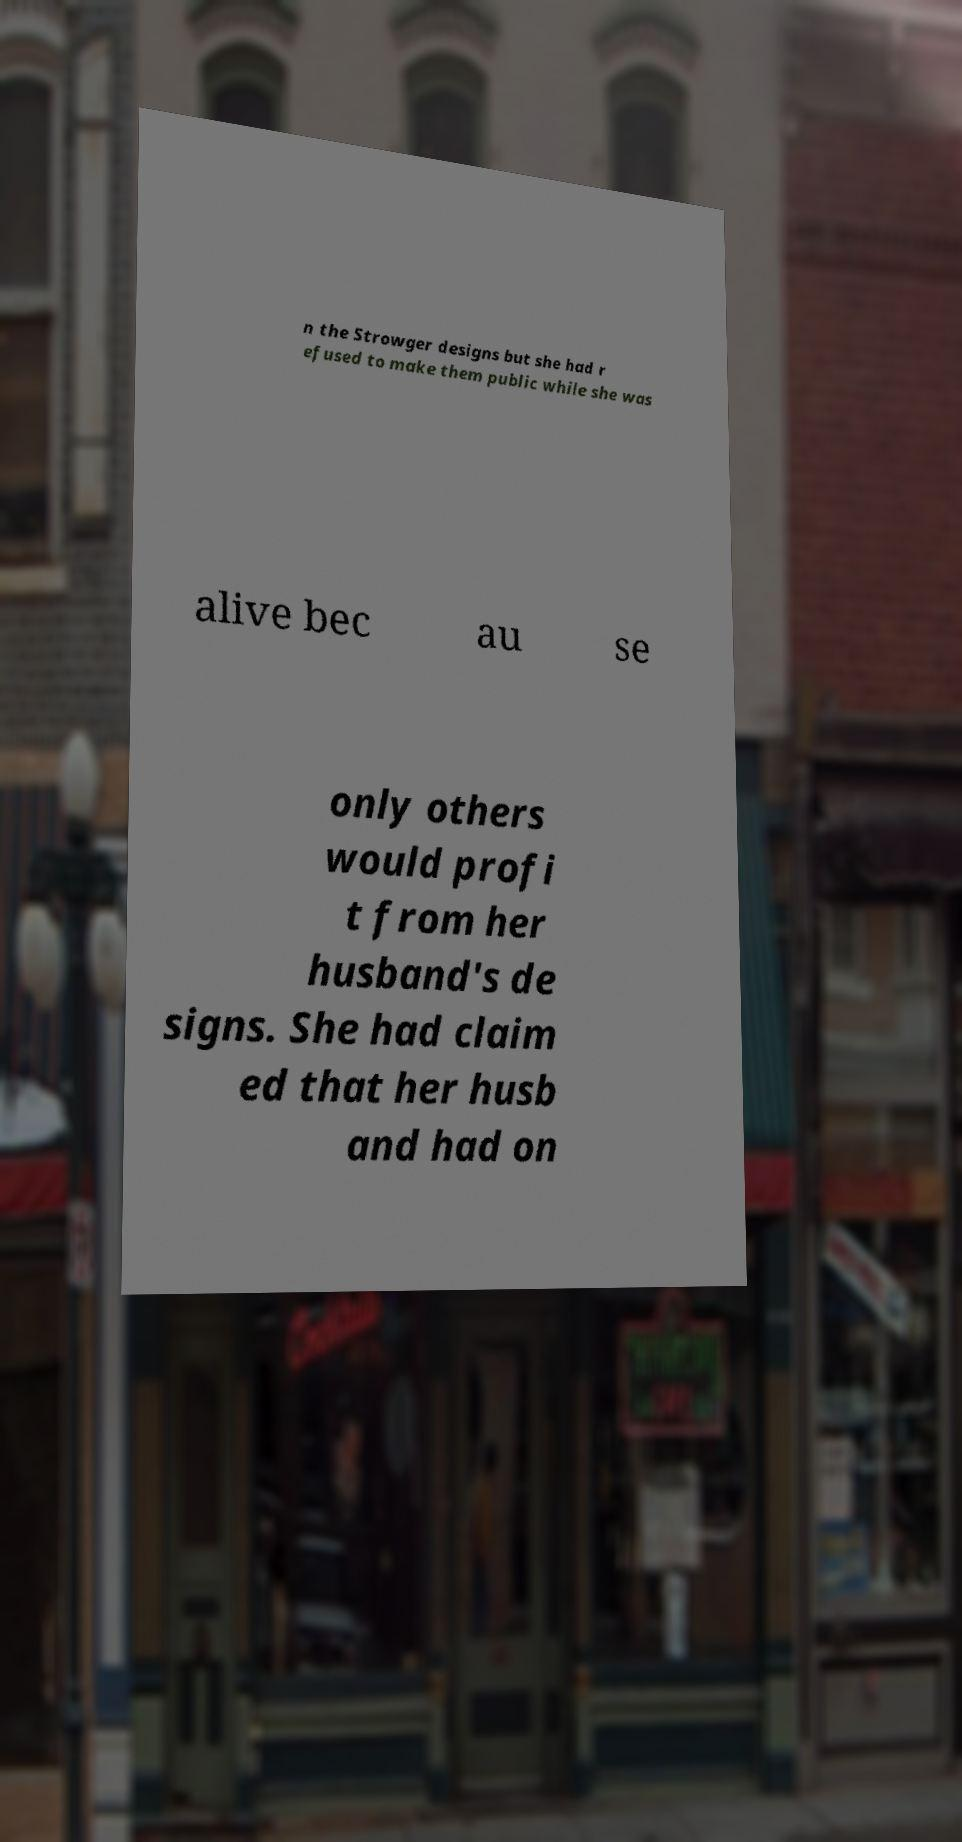Can you accurately transcribe the text from the provided image for me? n the Strowger designs but she had r efused to make them public while she was alive bec au se only others would profi t from her husband's de signs. She had claim ed that her husb and had on 